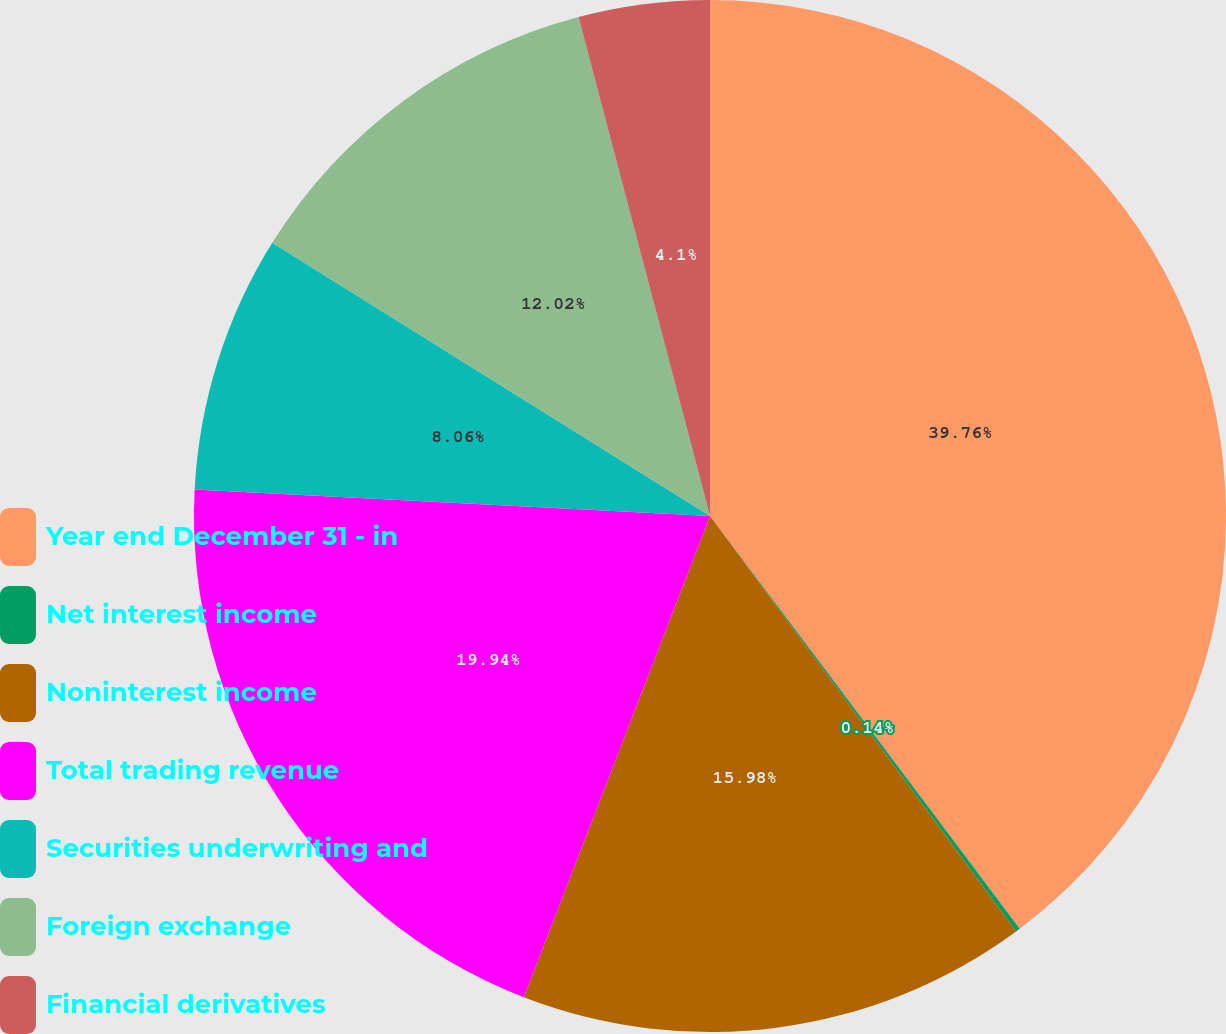Convert chart. <chart><loc_0><loc_0><loc_500><loc_500><pie_chart><fcel>Year end December 31 - in<fcel>Net interest income<fcel>Noninterest income<fcel>Total trading revenue<fcel>Securities underwriting and<fcel>Foreign exchange<fcel>Financial derivatives<nl><fcel>39.75%<fcel>0.14%<fcel>15.98%<fcel>19.94%<fcel>8.06%<fcel>12.02%<fcel>4.1%<nl></chart> 